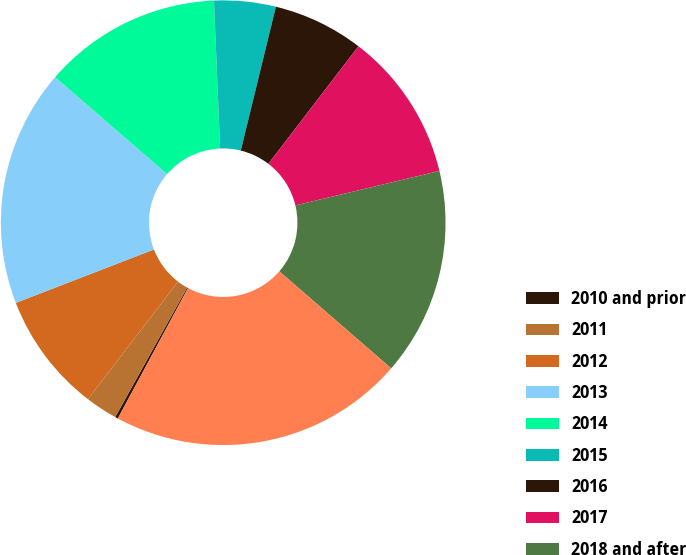<chart> <loc_0><loc_0><loc_500><loc_500><pie_chart><fcel>2010 and prior<fcel>2011<fcel>2012<fcel>2013<fcel>2014<fcel>2015<fcel>2016<fcel>2017<fcel>2018 and after<fcel>Total<nl><fcel>0.21%<fcel>2.34%<fcel>8.72%<fcel>17.23%<fcel>12.98%<fcel>4.47%<fcel>6.6%<fcel>10.85%<fcel>15.11%<fcel>21.49%<nl></chart> 